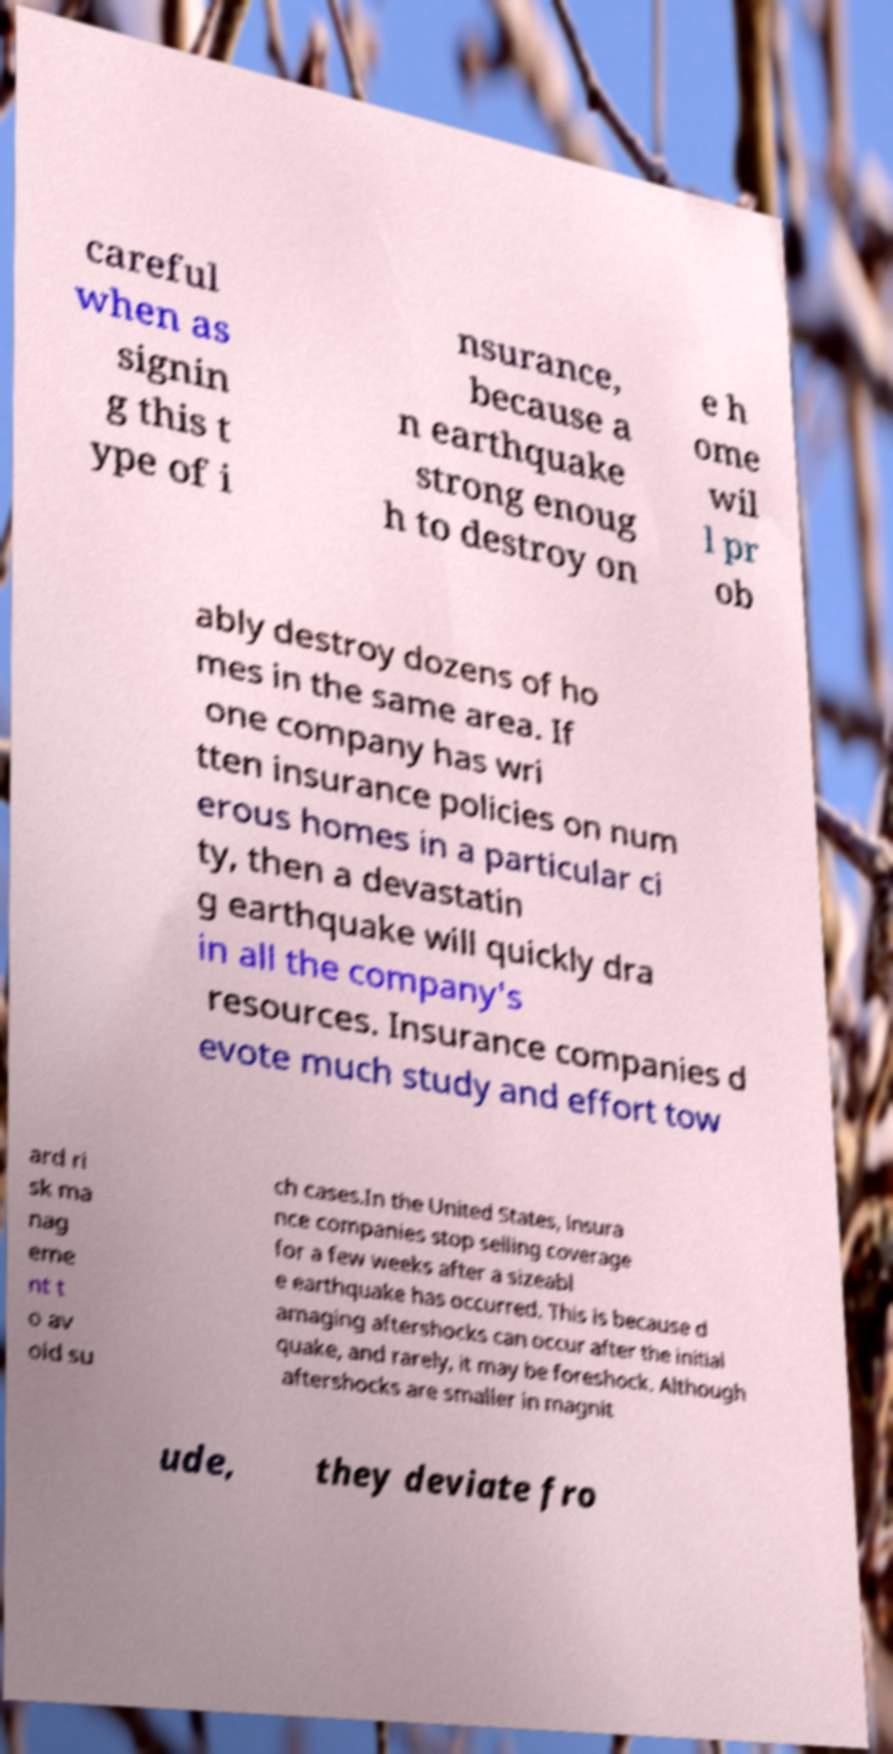Please read and relay the text visible in this image. What does it say? careful when as signin g this t ype of i nsurance, because a n earthquake strong enoug h to destroy on e h ome wil l pr ob ably destroy dozens of ho mes in the same area. If one company has wri tten insurance policies on num erous homes in a particular ci ty, then a devastatin g earthquake will quickly dra in all the company's resources. Insurance companies d evote much study and effort tow ard ri sk ma nag eme nt t o av oid su ch cases.In the United States, insura nce companies stop selling coverage for a few weeks after a sizeabl e earthquake has occurred. This is because d amaging aftershocks can occur after the initial quake, and rarely, it may be foreshock. Although aftershocks are smaller in magnit ude, they deviate fro 